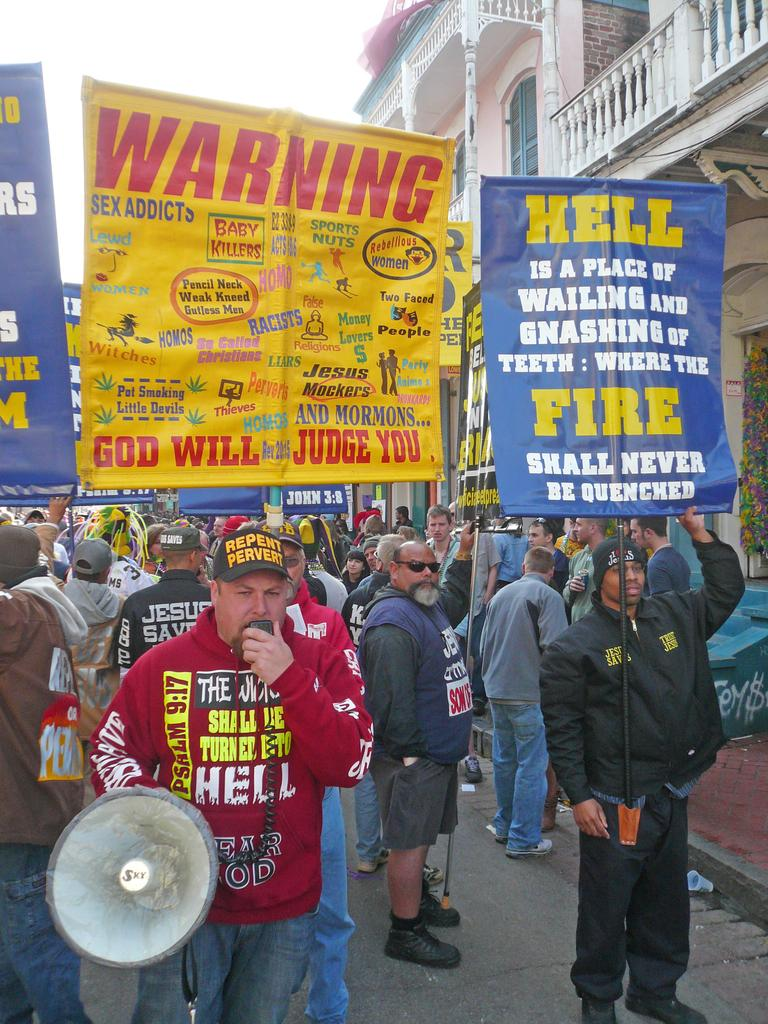What is the person in the image doing? The person is standing and speaking into a microphone. Are there any other people in the image? Yes, there are other people behind the person. What are the people behind the person holding? The people behind the person are holding placards. What can be seen in the background of the image? There are buildings visible in the image. Can you hear the bells ringing in the image? There are no bells present in the image, so it is not possible to hear them ringing. 